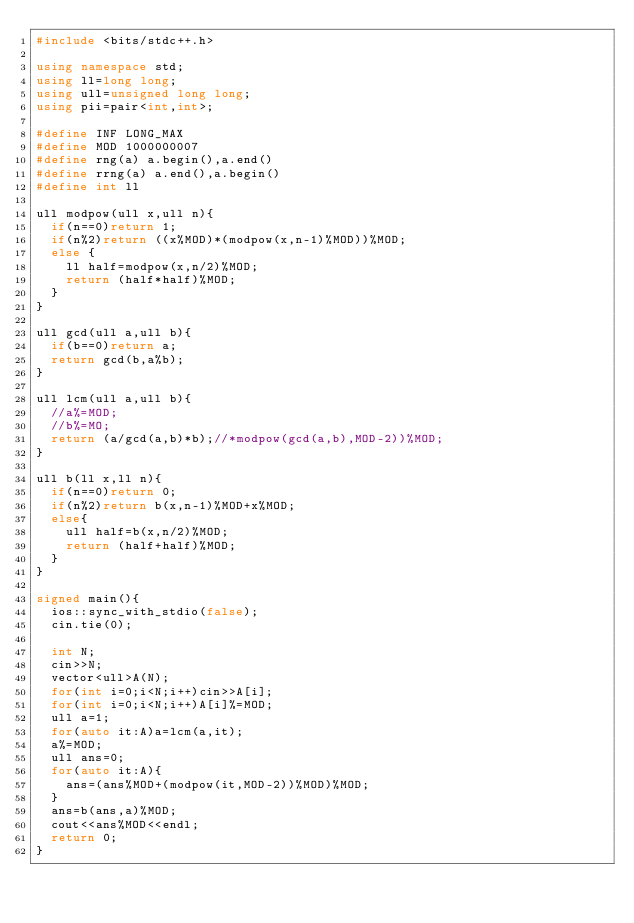<code> <loc_0><loc_0><loc_500><loc_500><_C++_>#include <bits/stdc++.h> 

using namespace std;
using ll=long long;
using ull=unsigned long long;
using pii=pair<int,int>;

#define INF LONG_MAX
#define MOD 1000000007
#define rng(a) a.begin(),a.end()
#define rrng(a) a.end(),a.begin()
#define int ll

ull modpow(ull x,ull n){
  if(n==0)return 1;
  if(n%2)return ((x%MOD)*(modpow(x,n-1)%MOD))%MOD;
  else {
    ll half=modpow(x,n/2)%MOD;
    return (half*half)%MOD;
  }
}

ull gcd(ull a,ull b){
  if(b==0)return a;
  return gcd(b,a%b);
}

ull lcm(ull a,ull b){
  //a%=MOD;
  //b%=MO;
  return (a/gcd(a,b)*b);//*modpow(gcd(a,b),MOD-2))%MOD;
}

ull b(ll x,ll n){
  if(n==0)return 0;
  if(n%2)return b(x,n-1)%MOD+x%MOD;
  else{
    ull half=b(x,n/2)%MOD;
    return (half+half)%MOD;
  }
}

signed main(){
  ios::sync_with_stdio(false);
  cin.tie(0);

  int N;
  cin>>N;
  vector<ull>A(N);
  for(int i=0;i<N;i++)cin>>A[i];
  for(int i=0;i<N;i++)A[i]%=MOD;
  ull a=1;
  for(auto it:A)a=lcm(a,it);
  a%=MOD;
  ull ans=0;
  for(auto it:A){
    ans=(ans%MOD+(modpow(it,MOD-2))%MOD)%MOD;
  }
  ans=b(ans,a)%MOD;
  cout<<ans%MOD<<endl;
  return 0;
}
</code> 